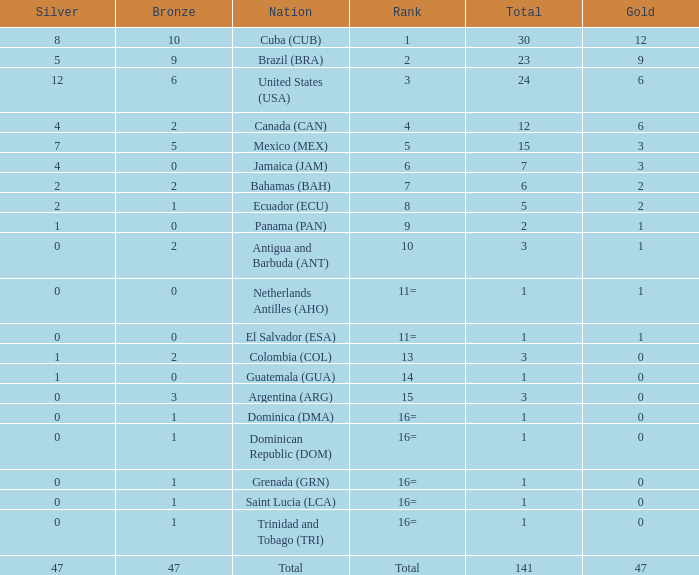What is the total gold with a total less than 1? None. 